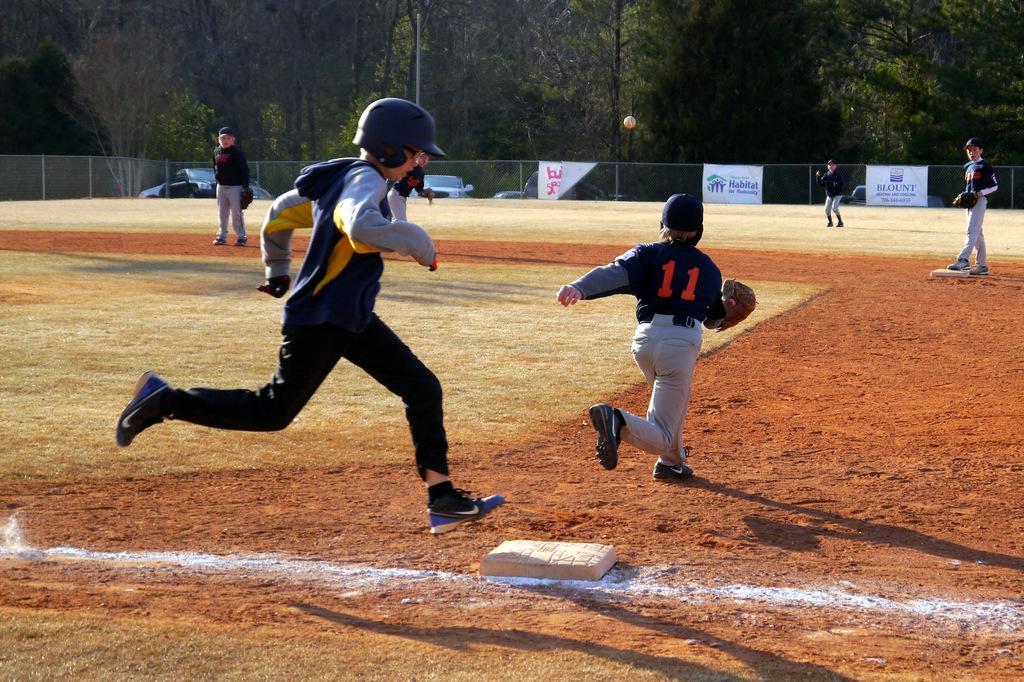How would you summarize this image in a sentence or two? In this image I can see few people are standing and few people are running. Back I can see the net fencing, trees, vehicles, pole and banners. 